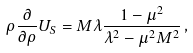Convert formula to latex. <formula><loc_0><loc_0><loc_500><loc_500>\rho \frac { \partial } { \partial \rho } U _ { S } = M \lambda \frac { 1 - \mu ^ { 2 } } { \lambda ^ { 2 } - \mu ^ { 2 } M ^ { 2 } } \, ,</formula> 